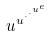<formula> <loc_0><loc_0><loc_500><loc_500>u ^ { u ^ { \cdot ^ { \cdot ^ { u ^ { e } } } } }</formula> 